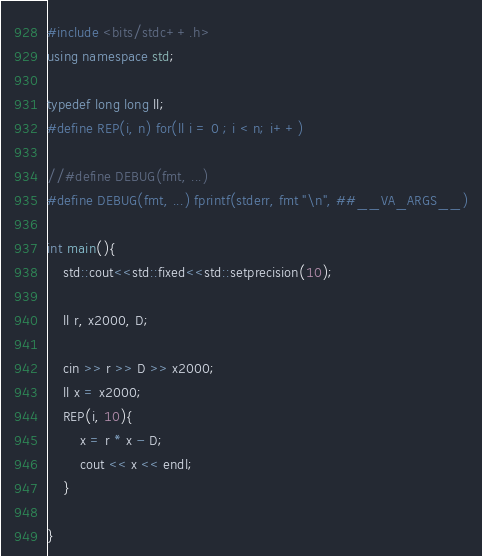Convert code to text. <code><loc_0><loc_0><loc_500><loc_500><_C++_>#include <bits/stdc++.h>
using namespace std;

typedef long long ll;
#define REP(i, n) for(ll i = 0 ; i < n; i++)

//#define DEBUG(fmt, ...)
#define DEBUG(fmt, ...) fprintf(stderr, fmt "\n", ##__VA_ARGS__)

int main(){
    std::cout<<std::fixed<<std::setprecision(10);

    ll r, x2000, D;

    cin >> r >> D >> x2000;
    ll x = x2000;
    REP(i, 10){
        x = r * x - D;
        cout << x << endl;
    }

}
</code> 